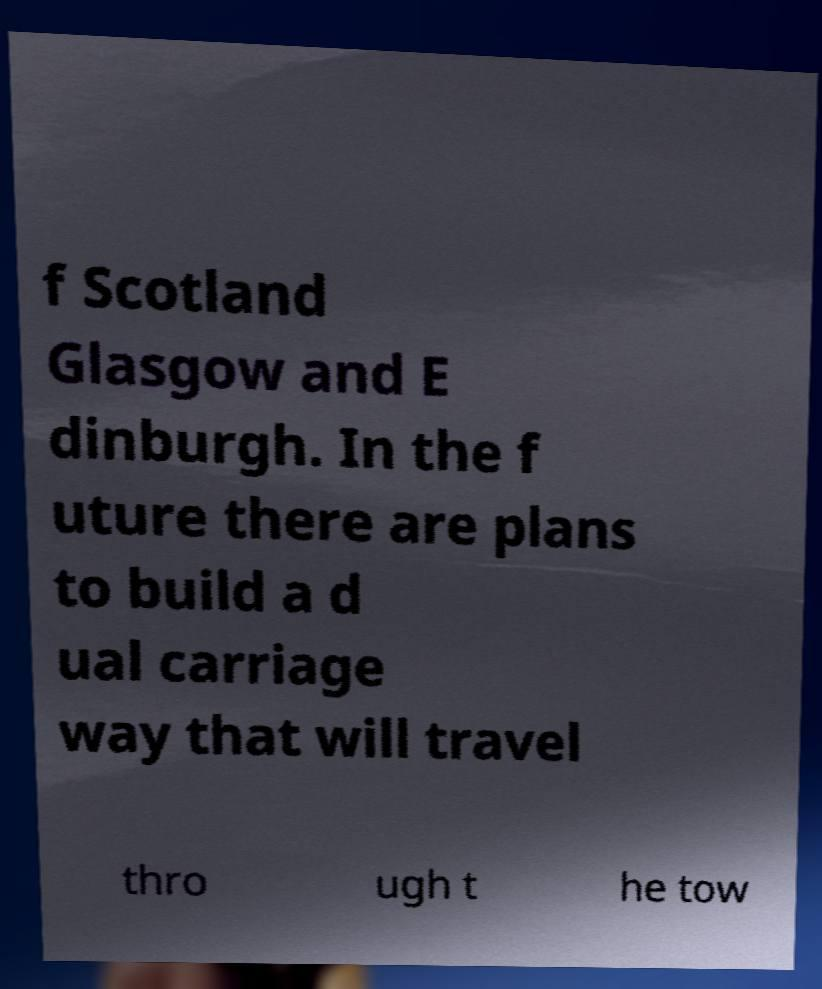Could you extract and type out the text from this image? f Scotland Glasgow and E dinburgh. In the f uture there are plans to build a d ual carriage way that will travel thro ugh t he tow 